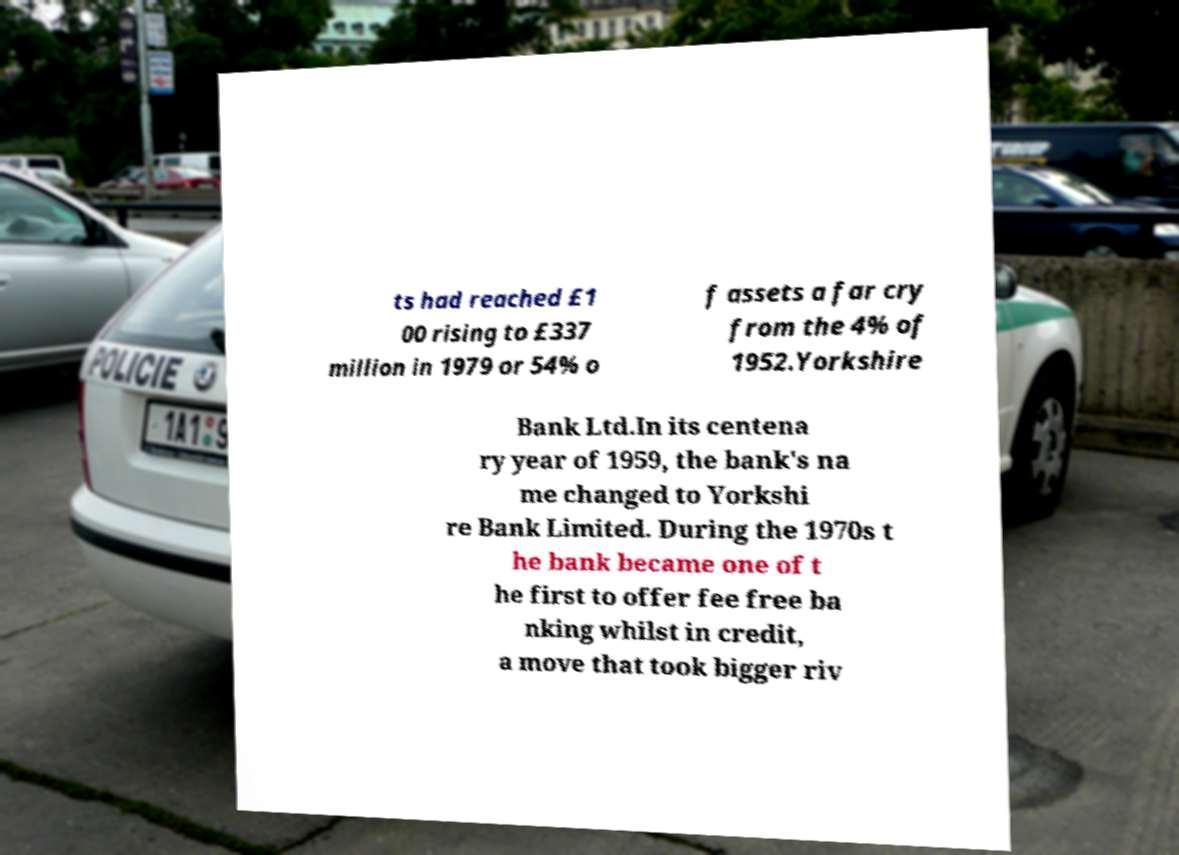What messages or text are displayed in this image? I need them in a readable, typed format. ts had reached £1 00 rising to £337 million in 1979 or 54% o f assets a far cry from the 4% of 1952.Yorkshire Bank Ltd.In its centena ry year of 1959, the bank's na me changed to Yorkshi re Bank Limited. During the 1970s t he bank became one of t he first to offer fee free ba nking whilst in credit, a move that took bigger riv 